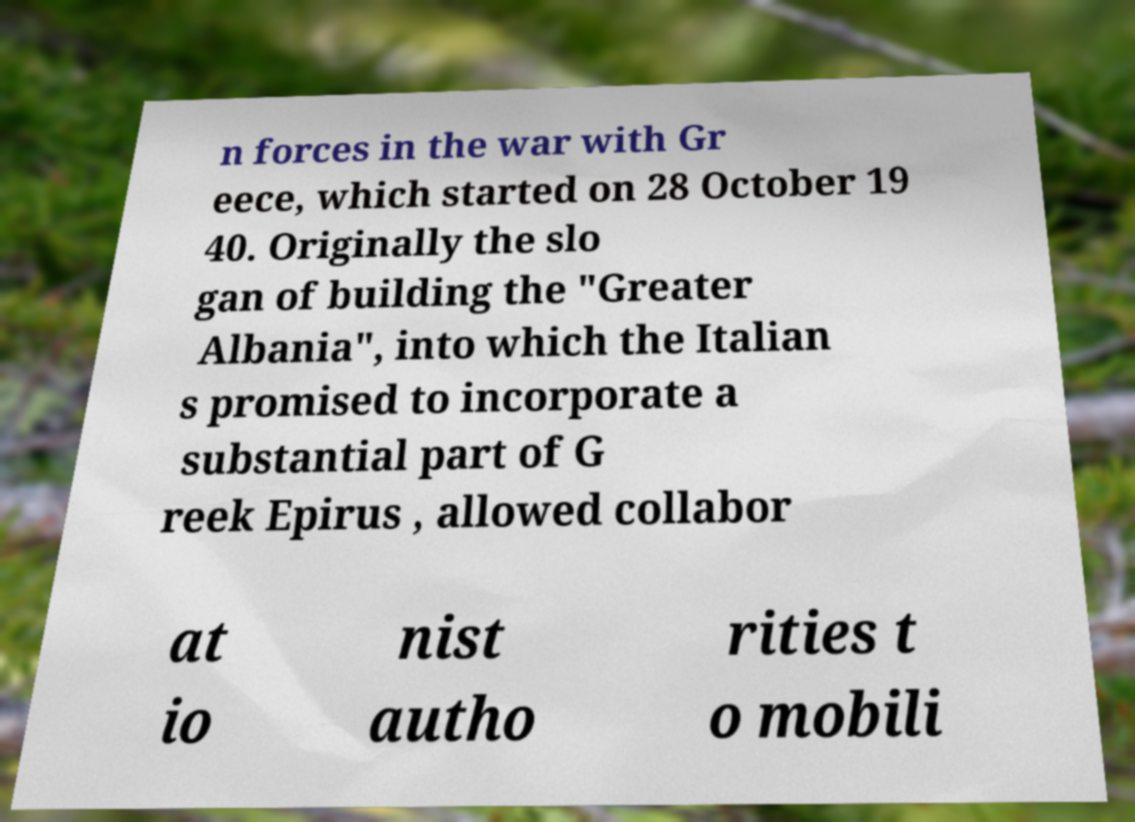I need the written content from this picture converted into text. Can you do that? n forces in the war with Gr eece, which started on 28 October 19 40. Originally the slo gan of building the "Greater Albania", into which the Italian s promised to incorporate a substantial part of G reek Epirus , allowed collabor at io nist autho rities t o mobili 